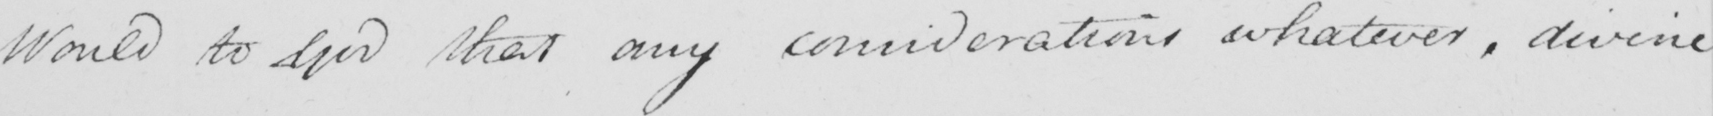Can you tell me what this handwritten text says? Would to God that any considerations whatever , divine 